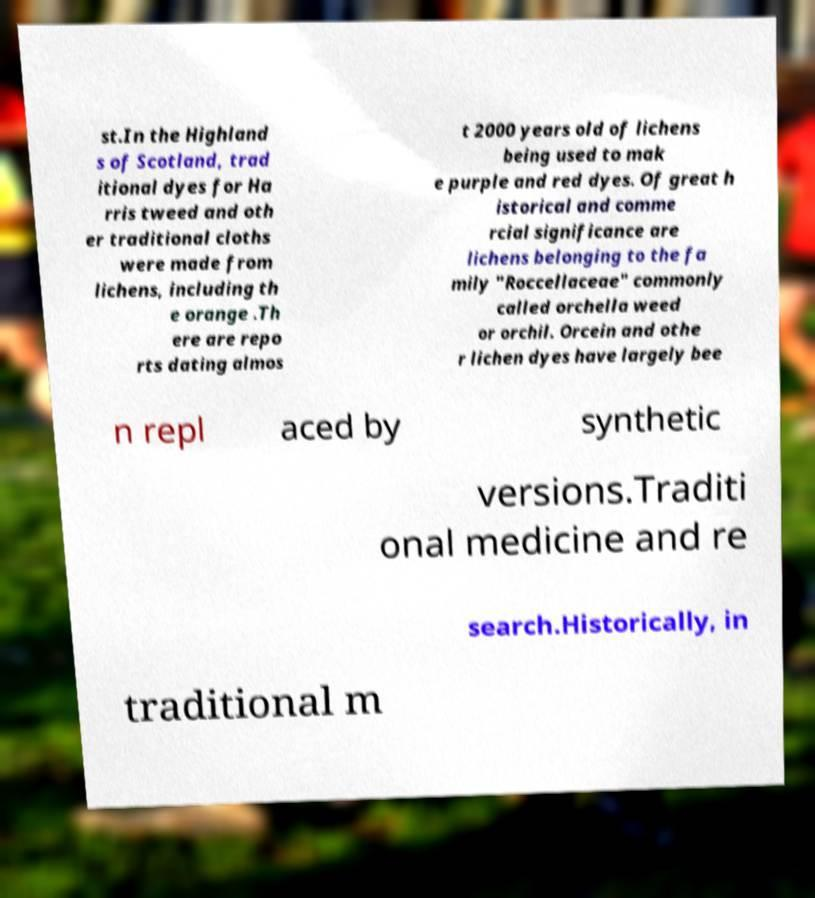Can you read and provide the text displayed in the image?This photo seems to have some interesting text. Can you extract and type it out for me? st.In the Highland s of Scotland, trad itional dyes for Ha rris tweed and oth er traditional cloths were made from lichens, including th e orange .Th ere are repo rts dating almos t 2000 years old of lichens being used to mak e purple and red dyes. Of great h istorical and comme rcial significance are lichens belonging to the fa mily "Roccellaceae" commonly called orchella weed or orchil. Orcein and othe r lichen dyes have largely bee n repl aced by synthetic versions.Traditi onal medicine and re search.Historically, in traditional m 